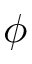Convert formula to latex. <formula><loc_0><loc_0><loc_500><loc_500>\phi</formula> 